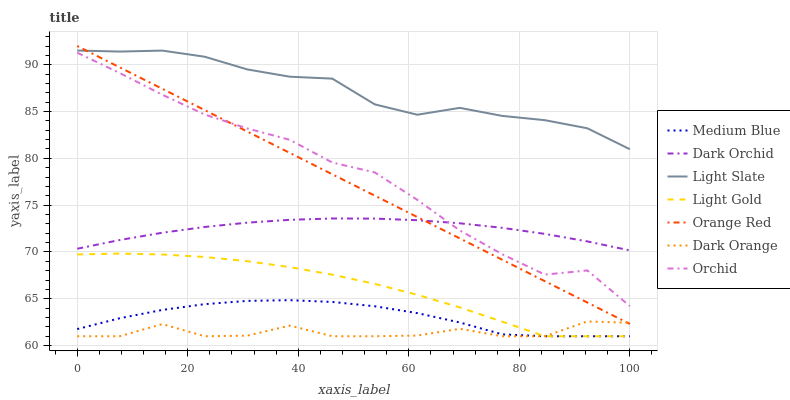Does Dark Orange have the minimum area under the curve?
Answer yes or no. Yes. Does Light Slate have the maximum area under the curve?
Answer yes or no. Yes. Does Medium Blue have the minimum area under the curve?
Answer yes or no. No. Does Medium Blue have the maximum area under the curve?
Answer yes or no. No. Is Orange Red the smoothest?
Answer yes or no. Yes. Is Dark Orange the roughest?
Answer yes or no. Yes. Is Light Slate the smoothest?
Answer yes or no. No. Is Light Slate the roughest?
Answer yes or no. No. Does Dark Orange have the lowest value?
Answer yes or no. Yes. Does Light Slate have the lowest value?
Answer yes or no. No. Does Orange Red have the highest value?
Answer yes or no. Yes. Does Light Slate have the highest value?
Answer yes or no. No. Is Dark Orange less than Orchid?
Answer yes or no. Yes. Is Light Slate greater than Medium Blue?
Answer yes or no. Yes. Does Orange Red intersect Dark Orange?
Answer yes or no. Yes. Is Orange Red less than Dark Orange?
Answer yes or no. No. Is Orange Red greater than Dark Orange?
Answer yes or no. No. Does Dark Orange intersect Orchid?
Answer yes or no. No. 